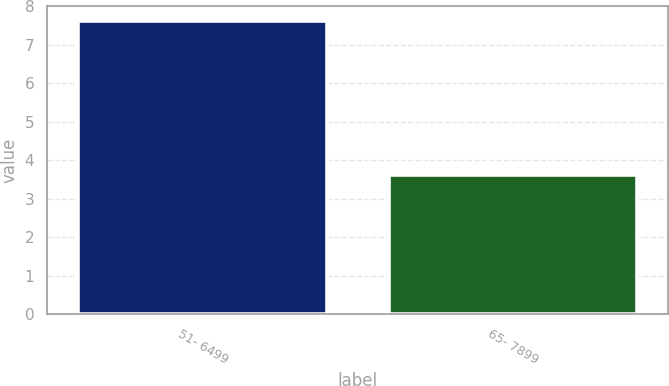Convert chart to OTSL. <chart><loc_0><loc_0><loc_500><loc_500><bar_chart><fcel>51- 6499<fcel>65- 7899<nl><fcel>7.62<fcel>3.62<nl></chart> 